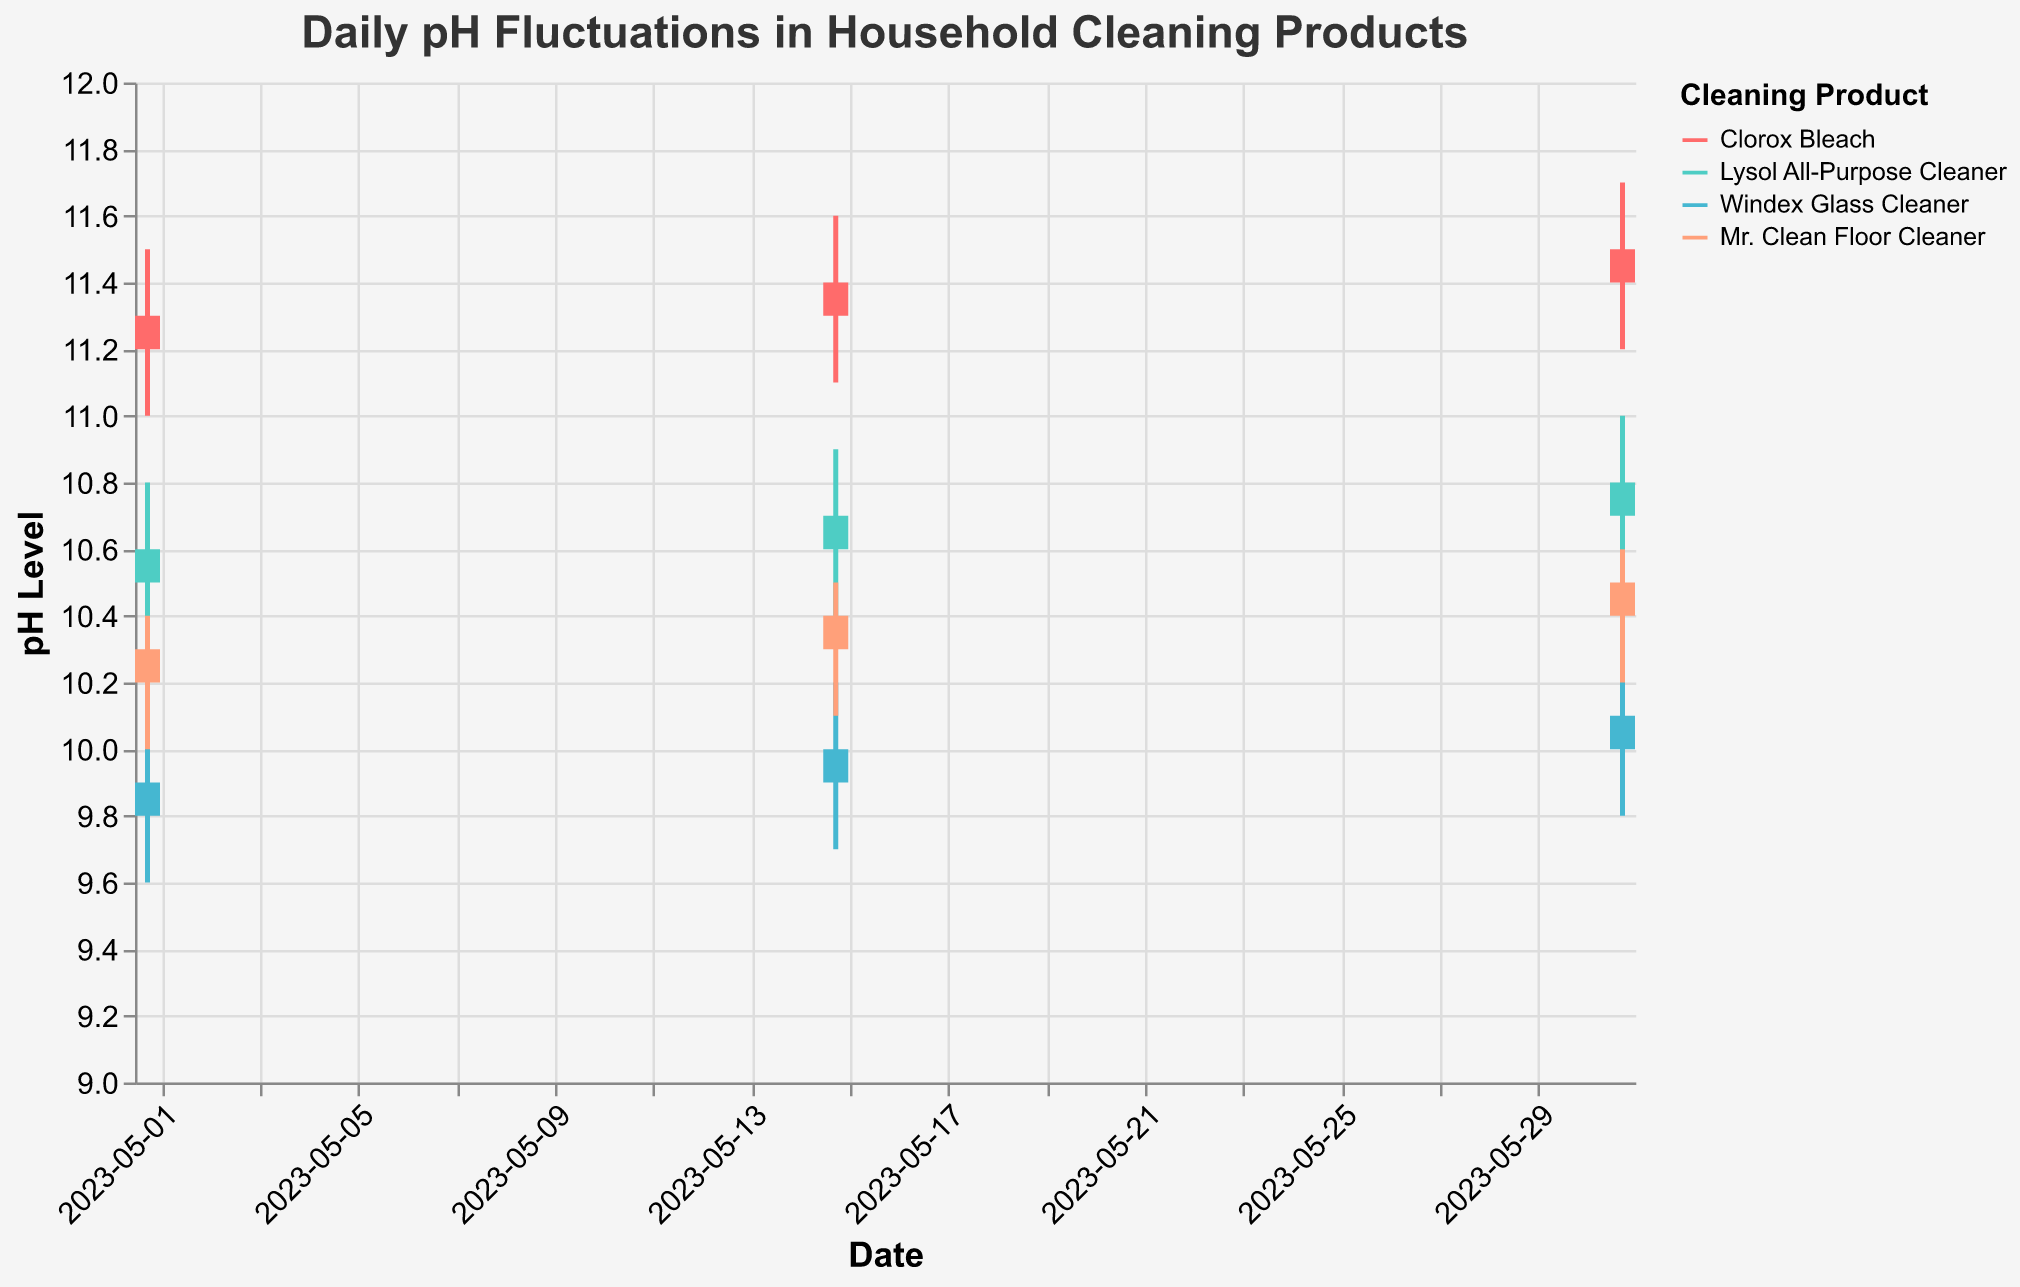What is the title of the chart? The title of the chart is displayed at the top of the figure and reads "Daily pH Fluctuations in Household Cleaning Products".
Answer: Daily pH Fluctuations in Household Cleaning Products Which product has the highest pH level on May 31, 2023? Look at the data points for May 31, 2023, and identify the product with the highest "High" value. Clorox Bleach has the highest pH level at 11.7.
Answer: Clorox Bleach What is the range of pH levels for Windex Glass Cleaner on May 01, 2023? The range of pH levels is calculated as the difference between the "High" and "Low" values for May 01, 2023. The pH range is 10.1 - 9.6 = 0.5.
Answer: 0.5 Which product experienced the largest pH fluctuation (High-Low) on May 15, 2023? Compare the "High" minus "Low" values for each product on May 15, 2023. Clorox Bleach has the largest fluctuation, with 11.6 - 11.1 = 0.5.
Answer: Clorox Bleach Between Clorox Bleach and Mr. Clean Floor Cleaner, which product had a higher closing pH level on May 15, 2023? Compare the "Close" values for Clorox Bleach and Mr. Clean Floor Cleaner on May 15, 2023. Clorox Bleach has a closing pH level of 11.4, while Mr. Clean Floor Cleaner has 10.4.
Answer: Clorox Bleach What is the average opening pH level of Lysol All-Purpose Cleaner over the three dates? To calculate the average, sum the opening pH levels of Lysol All-Purpose Cleaner on all three dates and divide by 3: (10.5 + 10.6 + 10.7) / 3 = 10.6.
Answer: 10.6 How does the closing pH level of Windex Glass Cleaner on May 31, 2023, compare to its opening pH level on the same day? Compare the "Close" and "Open" values of Windex Glass Cleaner on May 31, 2023. The closing pH level (10.1) is higher than the opening pH level (10.0).
Answer: Higher Which product had the most consistent pH level over the given dates based on the highest and lowest pH values? Consistency can be judged based on the smallest range between "High" and "Low" values across all dates. Mr. Clean Floor Cleaner has a pH range from 10.0 to 10.6, which is the smallest fluctuation.
Answer: Mr. Clean Floor Cleaner 